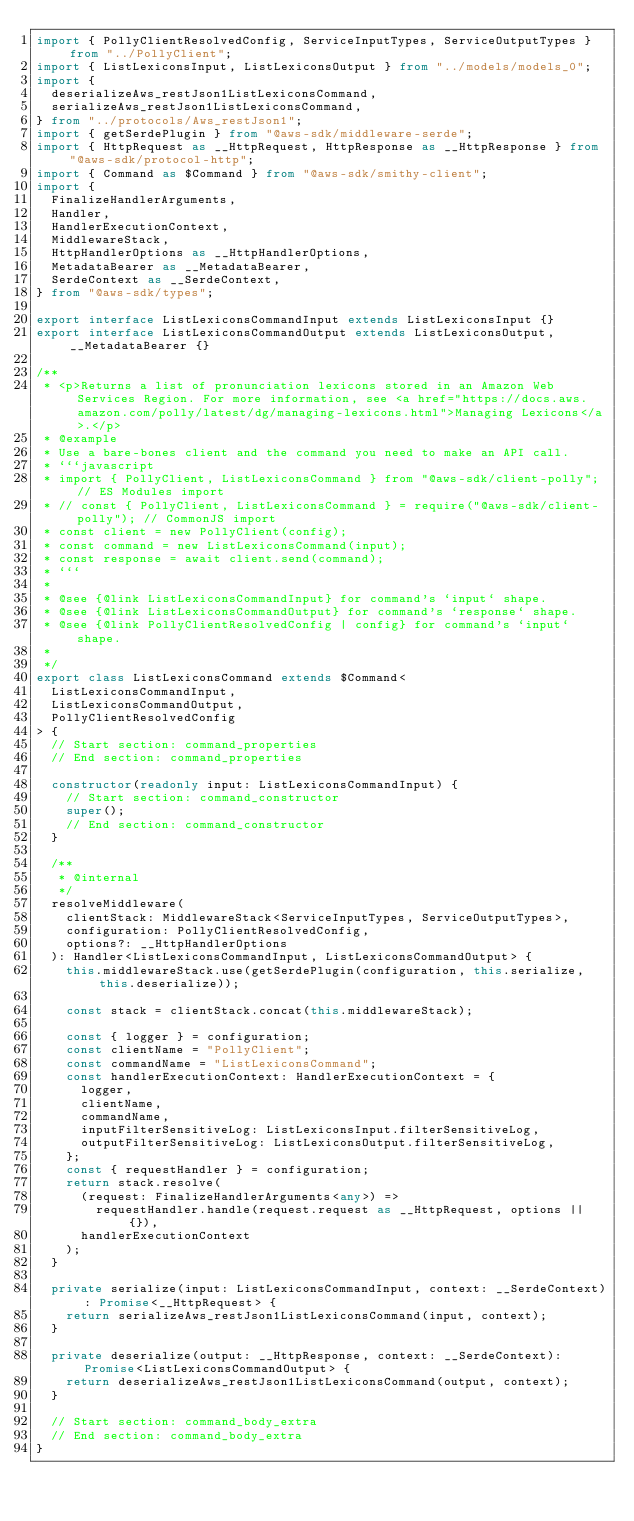<code> <loc_0><loc_0><loc_500><loc_500><_TypeScript_>import { PollyClientResolvedConfig, ServiceInputTypes, ServiceOutputTypes } from "../PollyClient";
import { ListLexiconsInput, ListLexiconsOutput } from "../models/models_0";
import {
  deserializeAws_restJson1ListLexiconsCommand,
  serializeAws_restJson1ListLexiconsCommand,
} from "../protocols/Aws_restJson1";
import { getSerdePlugin } from "@aws-sdk/middleware-serde";
import { HttpRequest as __HttpRequest, HttpResponse as __HttpResponse } from "@aws-sdk/protocol-http";
import { Command as $Command } from "@aws-sdk/smithy-client";
import {
  FinalizeHandlerArguments,
  Handler,
  HandlerExecutionContext,
  MiddlewareStack,
  HttpHandlerOptions as __HttpHandlerOptions,
  MetadataBearer as __MetadataBearer,
  SerdeContext as __SerdeContext,
} from "@aws-sdk/types";

export interface ListLexiconsCommandInput extends ListLexiconsInput {}
export interface ListLexiconsCommandOutput extends ListLexiconsOutput, __MetadataBearer {}

/**
 * <p>Returns a list of pronunciation lexicons stored in an Amazon Web Services Region. For more information, see <a href="https://docs.aws.amazon.com/polly/latest/dg/managing-lexicons.html">Managing Lexicons</a>.</p>
 * @example
 * Use a bare-bones client and the command you need to make an API call.
 * ```javascript
 * import { PollyClient, ListLexiconsCommand } from "@aws-sdk/client-polly"; // ES Modules import
 * // const { PollyClient, ListLexiconsCommand } = require("@aws-sdk/client-polly"); // CommonJS import
 * const client = new PollyClient(config);
 * const command = new ListLexiconsCommand(input);
 * const response = await client.send(command);
 * ```
 *
 * @see {@link ListLexiconsCommandInput} for command's `input` shape.
 * @see {@link ListLexiconsCommandOutput} for command's `response` shape.
 * @see {@link PollyClientResolvedConfig | config} for command's `input` shape.
 *
 */
export class ListLexiconsCommand extends $Command<
  ListLexiconsCommandInput,
  ListLexiconsCommandOutput,
  PollyClientResolvedConfig
> {
  // Start section: command_properties
  // End section: command_properties

  constructor(readonly input: ListLexiconsCommandInput) {
    // Start section: command_constructor
    super();
    // End section: command_constructor
  }

  /**
   * @internal
   */
  resolveMiddleware(
    clientStack: MiddlewareStack<ServiceInputTypes, ServiceOutputTypes>,
    configuration: PollyClientResolvedConfig,
    options?: __HttpHandlerOptions
  ): Handler<ListLexiconsCommandInput, ListLexiconsCommandOutput> {
    this.middlewareStack.use(getSerdePlugin(configuration, this.serialize, this.deserialize));

    const stack = clientStack.concat(this.middlewareStack);

    const { logger } = configuration;
    const clientName = "PollyClient";
    const commandName = "ListLexiconsCommand";
    const handlerExecutionContext: HandlerExecutionContext = {
      logger,
      clientName,
      commandName,
      inputFilterSensitiveLog: ListLexiconsInput.filterSensitiveLog,
      outputFilterSensitiveLog: ListLexiconsOutput.filterSensitiveLog,
    };
    const { requestHandler } = configuration;
    return stack.resolve(
      (request: FinalizeHandlerArguments<any>) =>
        requestHandler.handle(request.request as __HttpRequest, options || {}),
      handlerExecutionContext
    );
  }

  private serialize(input: ListLexiconsCommandInput, context: __SerdeContext): Promise<__HttpRequest> {
    return serializeAws_restJson1ListLexiconsCommand(input, context);
  }

  private deserialize(output: __HttpResponse, context: __SerdeContext): Promise<ListLexiconsCommandOutput> {
    return deserializeAws_restJson1ListLexiconsCommand(output, context);
  }

  // Start section: command_body_extra
  // End section: command_body_extra
}
</code> 